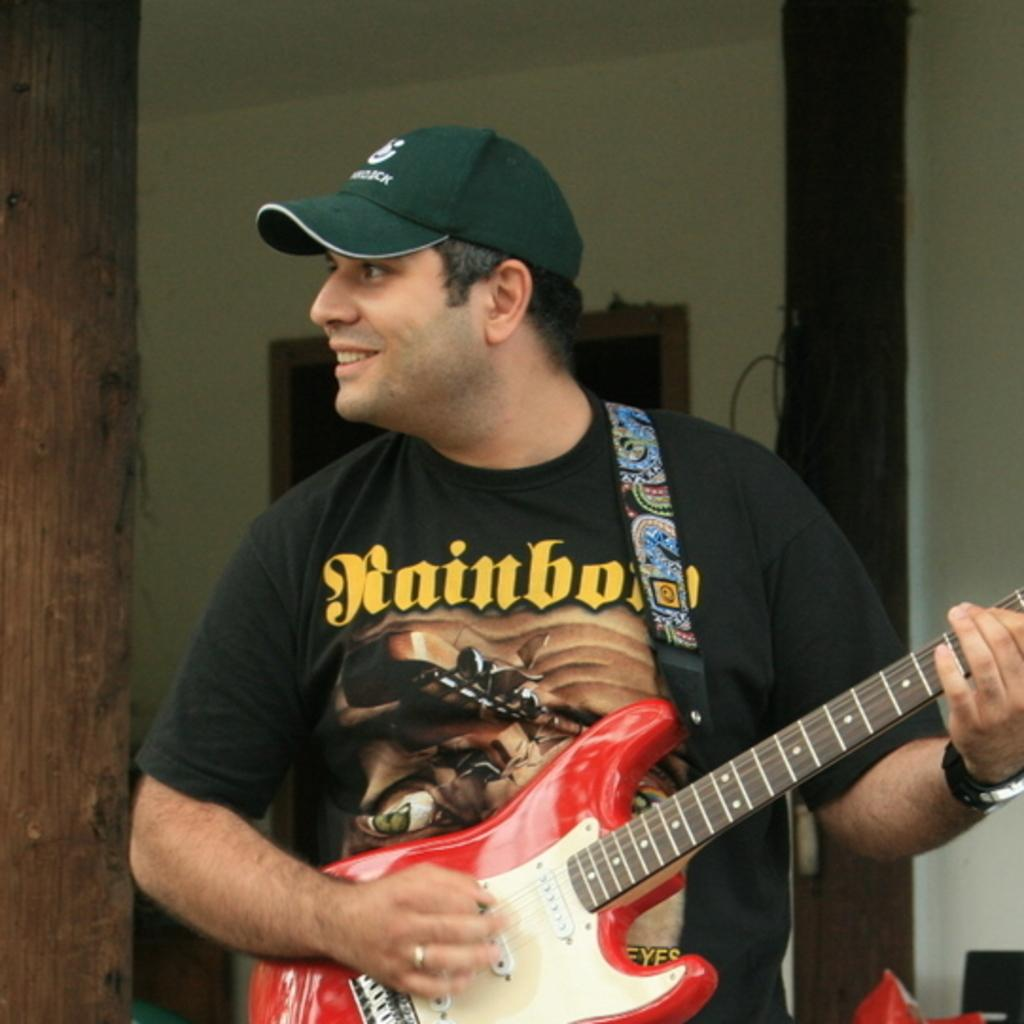What is the main subject of the image? The main subject of the image is a man. What is the man wearing in the image? The man is wearing a black T-shirt in the image. What is the man doing in the image? The man is holding and playing a guitar in the image. What accessory is the man wearing on his wrist? The man is wearing a wrist watch in the image. What headwear is the man wearing in the image? The man is wearing a cap on his head in the image. What can be seen in the background of the image? There is a tree trunk and a wall in the background of the image. What type of pencil is the man using to write a good-bye note in the image? There is no pencil or note visible in the image; the man is holding and playing a guitar. 